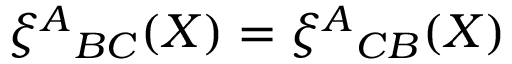Convert formula to latex. <formula><loc_0><loc_0><loc_500><loc_500>\xi ^ { A _ { B C } ( X ) = \xi ^ { A _ { C B } ( X )</formula> 